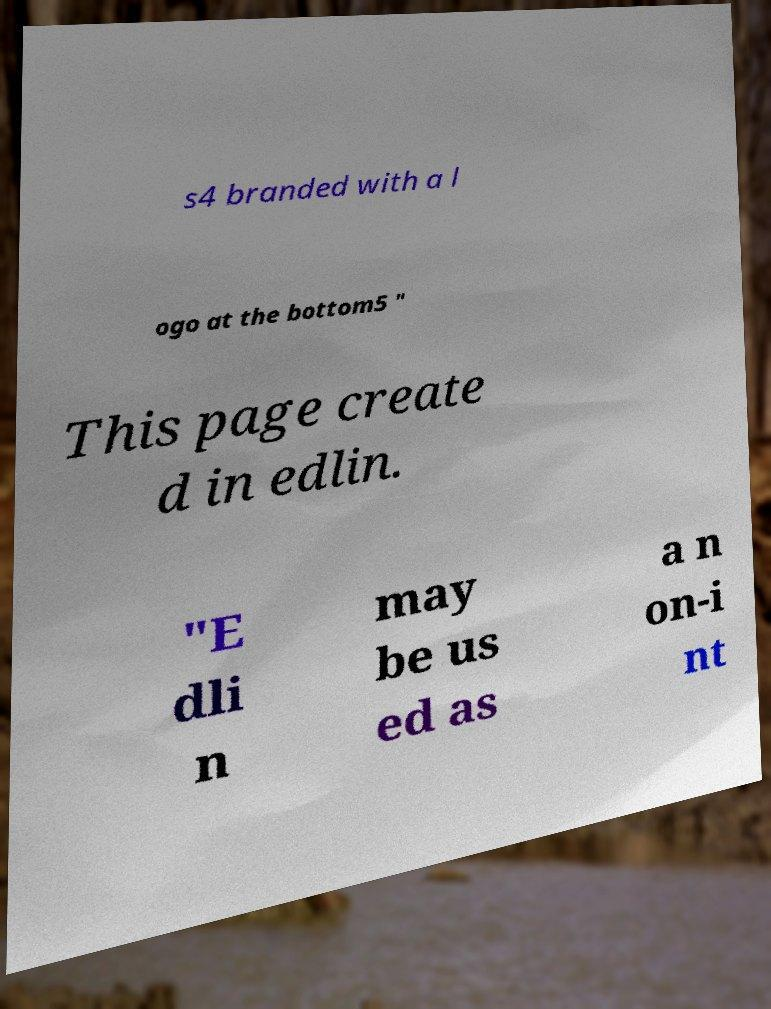Please identify and transcribe the text found in this image. s4 branded with a l ogo at the bottom5 " This page create d in edlin. "E dli n may be us ed as a n on-i nt 